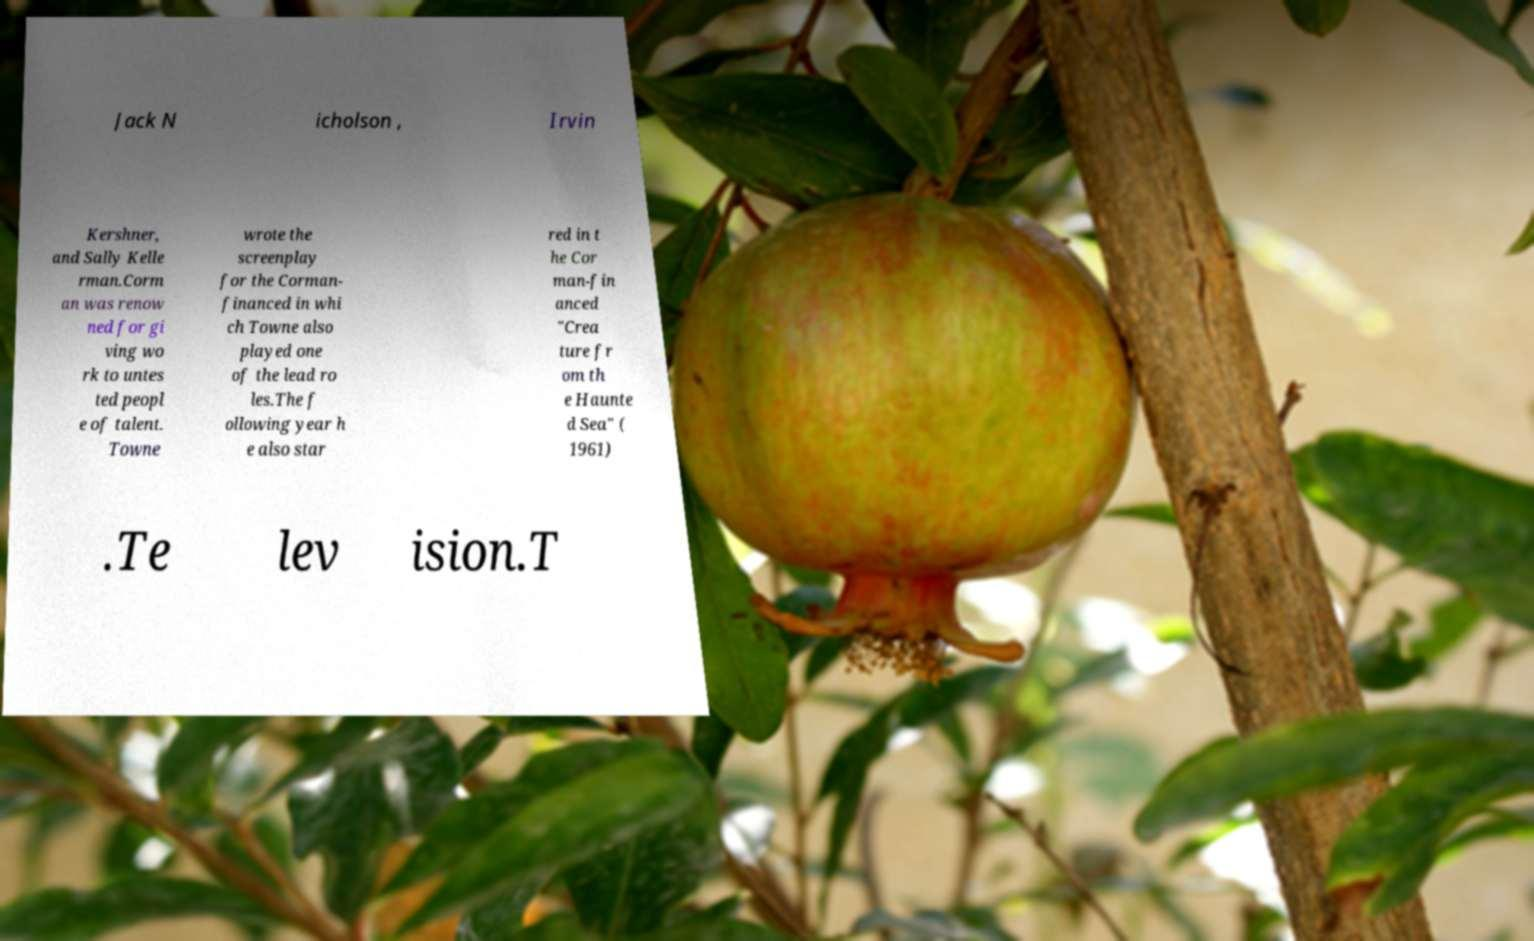I need the written content from this picture converted into text. Can you do that? Jack N icholson , Irvin Kershner, and Sally Kelle rman.Corm an was renow ned for gi ving wo rk to untes ted peopl e of talent. Towne wrote the screenplay for the Corman- financed in whi ch Towne also played one of the lead ro les.The f ollowing year h e also star red in t he Cor man-fin anced "Crea ture fr om th e Haunte d Sea" ( 1961) .Te lev ision.T 